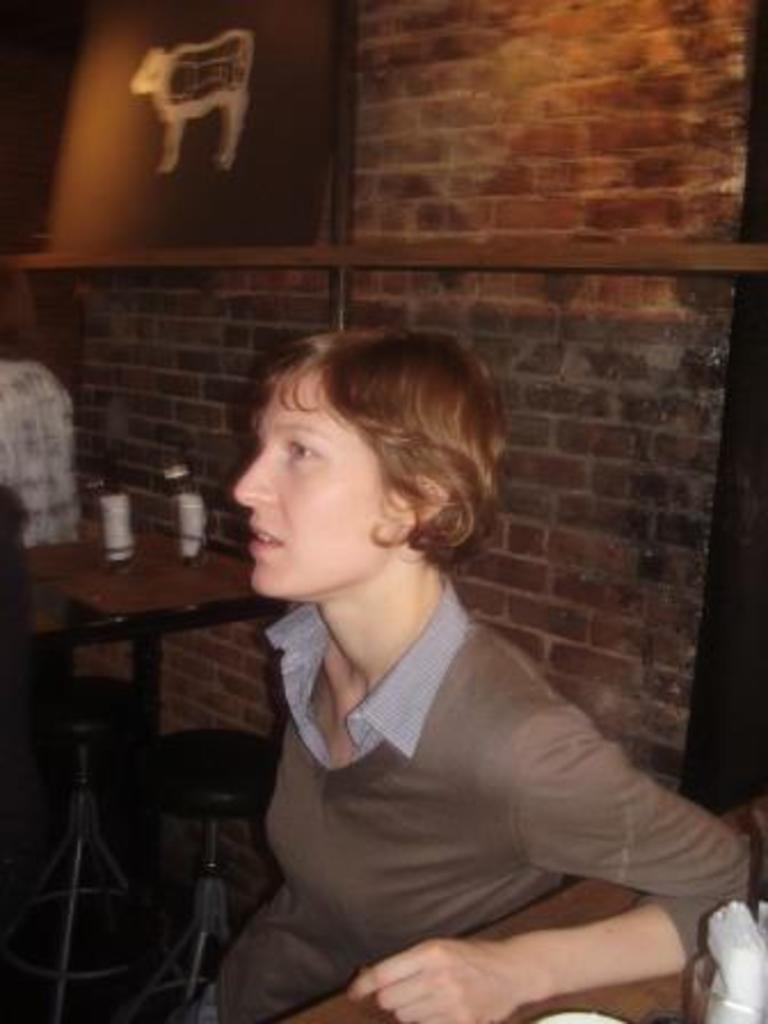Who is present in the image? There is a woman in the image. What type of furniture is visible in the image? There are stools and tables in the image. What is on the wall in the image? There is a board on a wall in the image. What is on the tables in the image? There are items on the tables in the image. How would you describe the quality of the image? The image is blurry. What book is the woman reading in the image? There is no book visible in the image, and the woman is not shown reading. 